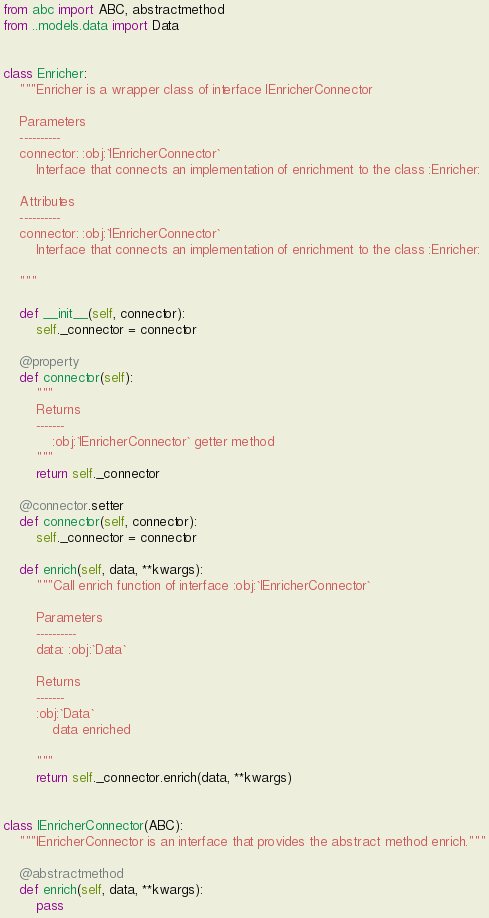Convert code to text. <code><loc_0><loc_0><loc_500><loc_500><_Python_>from abc import ABC, abstractmethod
from ..models.data import Data


class Enricher:
    """Enricher is a wrapper class of interface IEnricherConnector

    Parameters
    ----------
    connector: :obj:`IEnricherConnector`
        Interface that connects an implementation of enrichment to the class :Enricher:

    Attributes
    ----------
    connector: :obj:`IEnricherConnector`
        Interface that connects an implementation of enrichment to the class :Enricher:

    """

    def __init__(self, connector):
        self._connector = connector

    @property
    def connector(self):
        """
        Returns
        -------
            :obj:`IEnricherConnector` getter method
        """
        return self._connector

    @connector.setter
    def connector(self, connector):
        self._connector = connector

    def enrich(self, data, **kwargs):
        """Call enrich function of interface :obj:`IEnricherConnector`

        Parameters
        ----------
        data: :obj:`Data`

        Returns
        -------
        :obj:`Data`
            data enriched

        """
        return self._connector.enrich(data, **kwargs)


class IEnricherConnector(ABC):
    """IEnricherConnector is an interface that provides the abstract method enrich."""

    @abstractmethod
    def enrich(self, data, **kwargs):
        pass
</code> 